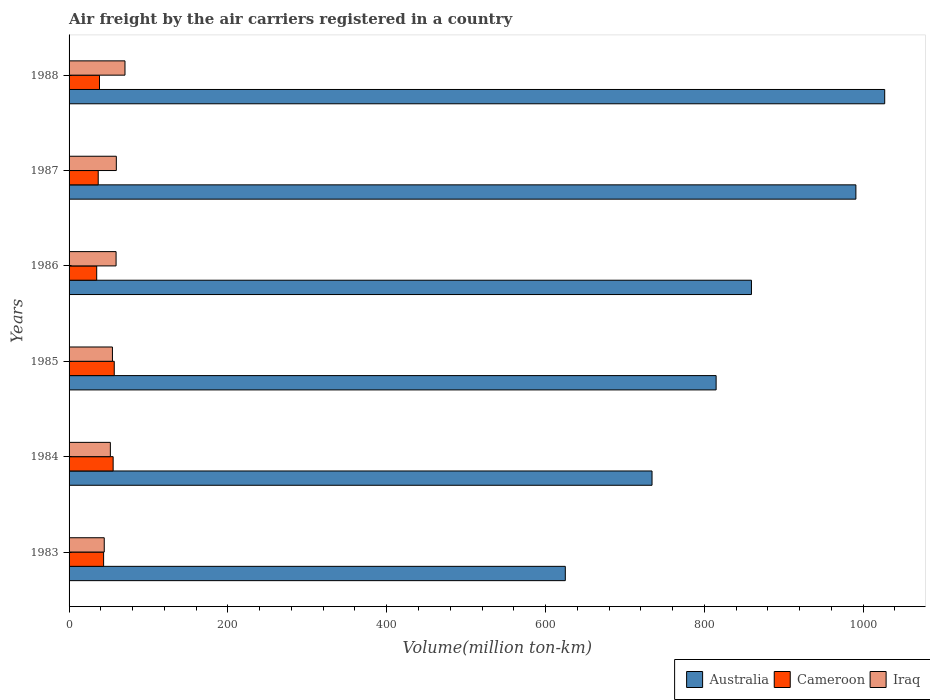How many different coloured bars are there?
Your answer should be compact. 3. Are the number of bars on each tick of the Y-axis equal?
Provide a short and direct response. Yes. How many bars are there on the 3rd tick from the top?
Your answer should be very brief. 3. What is the label of the 5th group of bars from the top?
Your response must be concise. 1984. In how many cases, is the number of bars for a given year not equal to the number of legend labels?
Your response must be concise. 0. What is the volume of the air carriers in Australia in 1987?
Offer a very short reply. 990.8. Across all years, what is the maximum volume of the air carriers in Australia?
Your response must be concise. 1027.1. Across all years, what is the minimum volume of the air carriers in Australia?
Give a very brief answer. 624.9. In which year was the volume of the air carriers in Cameroon maximum?
Provide a short and direct response. 1985. In which year was the volume of the air carriers in Australia minimum?
Ensure brevity in your answer.  1983. What is the total volume of the air carriers in Australia in the graph?
Provide a succinct answer. 5051. What is the difference between the volume of the air carriers in Australia in 1984 and that in 1988?
Your answer should be compact. -293. What is the difference between the volume of the air carriers in Australia in 1988 and the volume of the air carriers in Cameroon in 1984?
Your response must be concise. 971.6. What is the average volume of the air carriers in Iraq per year?
Offer a very short reply. 56.67. In the year 1984, what is the difference between the volume of the air carriers in Iraq and volume of the air carriers in Australia?
Ensure brevity in your answer.  -682.1. What is the ratio of the volume of the air carriers in Iraq in 1983 to that in 1986?
Keep it short and to the point. 0.75. Is the volume of the air carriers in Iraq in 1984 less than that in 1987?
Give a very brief answer. Yes. What is the difference between the highest and the second highest volume of the air carriers in Australia?
Provide a succinct answer. 36.3. What is the difference between the highest and the lowest volume of the air carriers in Cameroon?
Make the answer very short. 22.1. In how many years, is the volume of the air carriers in Cameroon greater than the average volume of the air carriers in Cameroon taken over all years?
Your answer should be compact. 2. Is the sum of the volume of the air carriers in Iraq in 1986 and 1987 greater than the maximum volume of the air carriers in Cameroon across all years?
Make the answer very short. Yes. What does the 1st bar from the top in 1983 represents?
Provide a short and direct response. Iraq. What does the 2nd bar from the bottom in 1987 represents?
Make the answer very short. Cameroon. How many bars are there?
Your response must be concise. 18. Are all the bars in the graph horizontal?
Provide a succinct answer. Yes. How many years are there in the graph?
Give a very brief answer. 6. What is the difference between two consecutive major ticks on the X-axis?
Provide a succinct answer. 200. Does the graph contain any zero values?
Make the answer very short. No. Does the graph contain grids?
Your response must be concise. No. How are the legend labels stacked?
Keep it short and to the point. Horizontal. What is the title of the graph?
Provide a short and direct response. Air freight by the air carriers registered in a country. What is the label or title of the X-axis?
Provide a succinct answer. Volume(million ton-km). What is the label or title of the Y-axis?
Give a very brief answer. Years. What is the Volume(million ton-km) in Australia in 1983?
Offer a terse response. 624.9. What is the Volume(million ton-km) of Cameroon in 1983?
Ensure brevity in your answer.  43.5. What is the Volume(million ton-km) in Iraq in 1983?
Provide a succinct answer. 44.3. What is the Volume(million ton-km) in Australia in 1984?
Provide a succinct answer. 734.1. What is the Volume(million ton-km) of Cameroon in 1984?
Provide a succinct answer. 55.5. What is the Volume(million ton-km) of Iraq in 1984?
Offer a very short reply. 52. What is the Volume(million ton-km) in Australia in 1985?
Provide a succinct answer. 814.8. What is the Volume(million ton-km) in Cameroon in 1985?
Your answer should be very brief. 56.9. What is the Volume(million ton-km) of Iraq in 1985?
Give a very brief answer. 54.6. What is the Volume(million ton-km) in Australia in 1986?
Your answer should be very brief. 859.3. What is the Volume(million ton-km) of Cameroon in 1986?
Ensure brevity in your answer.  34.8. What is the Volume(million ton-km) of Iraq in 1986?
Make the answer very short. 59.2. What is the Volume(million ton-km) in Australia in 1987?
Offer a very short reply. 990.8. What is the Volume(million ton-km) in Cameroon in 1987?
Offer a very short reply. 36.7. What is the Volume(million ton-km) of Iraq in 1987?
Ensure brevity in your answer.  59.5. What is the Volume(million ton-km) of Australia in 1988?
Offer a terse response. 1027.1. What is the Volume(million ton-km) in Cameroon in 1988?
Keep it short and to the point. 38.3. What is the Volume(million ton-km) of Iraq in 1988?
Your answer should be compact. 70.4. Across all years, what is the maximum Volume(million ton-km) of Australia?
Provide a succinct answer. 1027.1. Across all years, what is the maximum Volume(million ton-km) in Cameroon?
Ensure brevity in your answer.  56.9. Across all years, what is the maximum Volume(million ton-km) in Iraq?
Provide a succinct answer. 70.4. Across all years, what is the minimum Volume(million ton-km) in Australia?
Your answer should be compact. 624.9. Across all years, what is the minimum Volume(million ton-km) of Cameroon?
Make the answer very short. 34.8. Across all years, what is the minimum Volume(million ton-km) of Iraq?
Offer a terse response. 44.3. What is the total Volume(million ton-km) of Australia in the graph?
Your response must be concise. 5051. What is the total Volume(million ton-km) in Cameroon in the graph?
Give a very brief answer. 265.7. What is the total Volume(million ton-km) in Iraq in the graph?
Offer a terse response. 340. What is the difference between the Volume(million ton-km) of Australia in 1983 and that in 1984?
Your answer should be very brief. -109.2. What is the difference between the Volume(million ton-km) of Australia in 1983 and that in 1985?
Offer a very short reply. -189.9. What is the difference between the Volume(million ton-km) in Iraq in 1983 and that in 1985?
Your answer should be compact. -10.3. What is the difference between the Volume(million ton-km) in Australia in 1983 and that in 1986?
Offer a terse response. -234.4. What is the difference between the Volume(million ton-km) in Cameroon in 1983 and that in 1986?
Make the answer very short. 8.7. What is the difference between the Volume(million ton-km) of Iraq in 1983 and that in 1986?
Give a very brief answer. -14.9. What is the difference between the Volume(million ton-km) of Australia in 1983 and that in 1987?
Offer a very short reply. -365.9. What is the difference between the Volume(million ton-km) in Cameroon in 1983 and that in 1987?
Your answer should be compact. 6.8. What is the difference between the Volume(million ton-km) of Iraq in 1983 and that in 1987?
Provide a short and direct response. -15.2. What is the difference between the Volume(million ton-km) of Australia in 1983 and that in 1988?
Ensure brevity in your answer.  -402.2. What is the difference between the Volume(million ton-km) in Iraq in 1983 and that in 1988?
Your answer should be very brief. -26.1. What is the difference between the Volume(million ton-km) in Australia in 1984 and that in 1985?
Offer a very short reply. -80.7. What is the difference between the Volume(million ton-km) of Australia in 1984 and that in 1986?
Your answer should be compact. -125.2. What is the difference between the Volume(million ton-km) in Cameroon in 1984 and that in 1986?
Offer a very short reply. 20.7. What is the difference between the Volume(million ton-km) of Iraq in 1984 and that in 1986?
Keep it short and to the point. -7.2. What is the difference between the Volume(million ton-km) in Australia in 1984 and that in 1987?
Your response must be concise. -256.7. What is the difference between the Volume(million ton-km) of Cameroon in 1984 and that in 1987?
Provide a succinct answer. 18.8. What is the difference between the Volume(million ton-km) in Iraq in 1984 and that in 1987?
Make the answer very short. -7.5. What is the difference between the Volume(million ton-km) in Australia in 1984 and that in 1988?
Ensure brevity in your answer.  -293. What is the difference between the Volume(million ton-km) in Cameroon in 1984 and that in 1988?
Your answer should be compact. 17.2. What is the difference between the Volume(million ton-km) in Iraq in 1984 and that in 1988?
Offer a terse response. -18.4. What is the difference between the Volume(million ton-km) in Australia in 1985 and that in 1986?
Your response must be concise. -44.5. What is the difference between the Volume(million ton-km) in Cameroon in 1985 and that in 1986?
Provide a short and direct response. 22.1. What is the difference between the Volume(million ton-km) in Australia in 1985 and that in 1987?
Your answer should be compact. -176. What is the difference between the Volume(million ton-km) in Cameroon in 1985 and that in 1987?
Your answer should be very brief. 20.2. What is the difference between the Volume(million ton-km) of Iraq in 1985 and that in 1987?
Ensure brevity in your answer.  -4.9. What is the difference between the Volume(million ton-km) in Australia in 1985 and that in 1988?
Offer a terse response. -212.3. What is the difference between the Volume(million ton-km) in Cameroon in 1985 and that in 1988?
Make the answer very short. 18.6. What is the difference between the Volume(million ton-km) in Iraq in 1985 and that in 1988?
Ensure brevity in your answer.  -15.8. What is the difference between the Volume(million ton-km) in Australia in 1986 and that in 1987?
Provide a succinct answer. -131.5. What is the difference between the Volume(million ton-km) in Iraq in 1986 and that in 1987?
Make the answer very short. -0.3. What is the difference between the Volume(million ton-km) of Australia in 1986 and that in 1988?
Your answer should be very brief. -167.8. What is the difference between the Volume(million ton-km) in Cameroon in 1986 and that in 1988?
Your answer should be very brief. -3.5. What is the difference between the Volume(million ton-km) of Iraq in 1986 and that in 1988?
Your response must be concise. -11.2. What is the difference between the Volume(million ton-km) of Australia in 1987 and that in 1988?
Provide a succinct answer. -36.3. What is the difference between the Volume(million ton-km) of Iraq in 1987 and that in 1988?
Your response must be concise. -10.9. What is the difference between the Volume(million ton-km) of Australia in 1983 and the Volume(million ton-km) of Cameroon in 1984?
Provide a short and direct response. 569.4. What is the difference between the Volume(million ton-km) in Australia in 1983 and the Volume(million ton-km) in Iraq in 1984?
Make the answer very short. 572.9. What is the difference between the Volume(million ton-km) in Cameroon in 1983 and the Volume(million ton-km) in Iraq in 1984?
Offer a very short reply. -8.5. What is the difference between the Volume(million ton-km) in Australia in 1983 and the Volume(million ton-km) in Cameroon in 1985?
Ensure brevity in your answer.  568. What is the difference between the Volume(million ton-km) of Australia in 1983 and the Volume(million ton-km) of Iraq in 1985?
Provide a short and direct response. 570.3. What is the difference between the Volume(million ton-km) in Cameroon in 1983 and the Volume(million ton-km) in Iraq in 1985?
Offer a terse response. -11.1. What is the difference between the Volume(million ton-km) of Australia in 1983 and the Volume(million ton-km) of Cameroon in 1986?
Provide a succinct answer. 590.1. What is the difference between the Volume(million ton-km) of Australia in 1983 and the Volume(million ton-km) of Iraq in 1986?
Make the answer very short. 565.7. What is the difference between the Volume(million ton-km) of Cameroon in 1983 and the Volume(million ton-km) of Iraq in 1986?
Provide a short and direct response. -15.7. What is the difference between the Volume(million ton-km) in Australia in 1983 and the Volume(million ton-km) in Cameroon in 1987?
Provide a succinct answer. 588.2. What is the difference between the Volume(million ton-km) in Australia in 1983 and the Volume(million ton-km) in Iraq in 1987?
Keep it short and to the point. 565.4. What is the difference between the Volume(million ton-km) in Cameroon in 1983 and the Volume(million ton-km) in Iraq in 1987?
Offer a very short reply. -16. What is the difference between the Volume(million ton-km) of Australia in 1983 and the Volume(million ton-km) of Cameroon in 1988?
Provide a succinct answer. 586.6. What is the difference between the Volume(million ton-km) of Australia in 1983 and the Volume(million ton-km) of Iraq in 1988?
Make the answer very short. 554.5. What is the difference between the Volume(million ton-km) in Cameroon in 1983 and the Volume(million ton-km) in Iraq in 1988?
Your answer should be compact. -26.9. What is the difference between the Volume(million ton-km) of Australia in 1984 and the Volume(million ton-km) of Cameroon in 1985?
Your response must be concise. 677.2. What is the difference between the Volume(million ton-km) of Australia in 1984 and the Volume(million ton-km) of Iraq in 1985?
Make the answer very short. 679.5. What is the difference between the Volume(million ton-km) in Cameroon in 1984 and the Volume(million ton-km) in Iraq in 1985?
Your answer should be compact. 0.9. What is the difference between the Volume(million ton-km) in Australia in 1984 and the Volume(million ton-km) in Cameroon in 1986?
Keep it short and to the point. 699.3. What is the difference between the Volume(million ton-km) of Australia in 1984 and the Volume(million ton-km) of Iraq in 1986?
Ensure brevity in your answer.  674.9. What is the difference between the Volume(million ton-km) in Australia in 1984 and the Volume(million ton-km) in Cameroon in 1987?
Your answer should be compact. 697.4. What is the difference between the Volume(million ton-km) of Australia in 1984 and the Volume(million ton-km) of Iraq in 1987?
Your answer should be compact. 674.6. What is the difference between the Volume(million ton-km) in Cameroon in 1984 and the Volume(million ton-km) in Iraq in 1987?
Ensure brevity in your answer.  -4. What is the difference between the Volume(million ton-km) in Australia in 1984 and the Volume(million ton-km) in Cameroon in 1988?
Provide a succinct answer. 695.8. What is the difference between the Volume(million ton-km) of Australia in 1984 and the Volume(million ton-km) of Iraq in 1988?
Give a very brief answer. 663.7. What is the difference between the Volume(million ton-km) in Cameroon in 1984 and the Volume(million ton-km) in Iraq in 1988?
Provide a succinct answer. -14.9. What is the difference between the Volume(million ton-km) of Australia in 1985 and the Volume(million ton-km) of Cameroon in 1986?
Provide a succinct answer. 780. What is the difference between the Volume(million ton-km) of Australia in 1985 and the Volume(million ton-km) of Iraq in 1986?
Offer a terse response. 755.6. What is the difference between the Volume(million ton-km) of Cameroon in 1985 and the Volume(million ton-km) of Iraq in 1986?
Your answer should be compact. -2.3. What is the difference between the Volume(million ton-km) in Australia in 1985 and the Volume(million ton-km) in Cameroon in 1987?
Offer a very short reply. 778.1. What is the difference between the Volume(million ton-km) in Australia in 1985 and the Volume(million ton-km) in Iraq in 1987?
Offer a very short reply. 755.3. What is the difference between the Volume(million ton-km) in Australia in 1985 and the Volume(million ton-km) in Cameroon in 1988?
Provide a succinct answer. 776.5. What is the difference between the Volume(million ton-km) in Australia in 1985 and the Volume(million ton-km) in Iraq in 1988?
Provide a short and direct response. 744.4. What is the difference between the Volume(million ton-km) of Australia in 1986 and the Volume(million ton-km) of Cameroon in 1987?
Offer a very short reply. 822.6. What is the difference between the Volume(million ton-km) in Australia in 1986 and the Volume(million ton-km) in Iraq in 1987?
Keep it short and to the point. 799.8. What is the difference between the Volume(million ton-km) of Cameroon in 1986 and the Volume(million ton-km) of Iraq in 1987?
Offer a very short reply. -24.7. What is the difference between the Volume(million ton-km) in Australia in 1986 and the Volume(million ton-km) in Cameroon in 1988?
Your answer should be very brief. 821. What is the difference between the Volume(million ton-km) in Australia in 1986 and the Volume(million ton-km) in Iraq in 1988?
Give a very brief answer. 788.9. What is the difference between the Volume(million ton-km) of Cameroon in 1986 and the Volume(million ton-km) of Iraq in 1988?
Offer a terse response. -35.6. What is the difference between the Volume(million ton-km) in Australia in 1987 and the Volume(million ton-km) in Cameroon in 1988?
Your answer should be very brief. 952.5. What is the difference between the Volume(million ton-km) in Australia in 1987 and the Volume(million ton-km) in Iraq in 1988?
Your answer should be very brief. 920.4. What is the difference between the Volume(million ton-km) of Cameroon in 1987 and the Volume(million ton-km) of Iraq in 1988?
Your answer should be very brief. -33.7. What is the average Volume(million ton-km) of Australia per year?
Make the answer very short. 841.83. What is the average Volume(million ton-km) in Cameroon per year?
Make the answer very short. 44.28. What is the average Volume(million ton-km) in Iraq per year?
Ensure brevity in your answer.  56.67. In the year 1983, what is the difference between the Volume(million ton-km) in Australia and Volume(million ton-km) in Cameroon?
Make the answer very short. 581.4. In the year 1983, what is the difference between the Volume(million ton-km) in Australia and Volume(million ton-km) in Iraq?
Make the answer very short. 580.6. In the year 1983, what is the difference between the Volume(million ton-km) of Cameroon and Volume(million ton-km) of Iraq?
Give a very brief answer. -0.8. In the year 1984, what is the difference between the Volume(million ton-km) of Australia and Volume(million ton-km) of Cameroon?
Give a very brief answer. 678.6. In the year 1984, what is the difference between the Volume(million ton-km) of Australia and Volume(million ton-km) of Iraq?
Give a very brief answer. 682.1. In the year 1985, what is the difference between the Volume(million ton-km) in Australia and Volume(million ton-km) in Cameroon?
Give a very brief answer. 757.9. In the year 1985, what is the difference between the Volume(million ton-km) of Australia and Volume(million ton-km) of Iraq?
Your answer should be very brief. 760.2. In the year 1986, what is the difference between the Volume(million ton-km) of Australia and Volume(million ton-km) of Cameroon?
Keep it short and to the point. 824.5. In the year 1986, what is the difference between the Volume(million ton-km) of Australia and Volume(million ton-km) of Iraq?
Provide a succinct answer. 800.1. In the year 1986, what is the difference between the Volume(million ton-km) of Cameroon and Volume(million ton-km) of Iraq?
Your answer should be very brief. -24.4. In the year 1987, what is the difference between the Volume(million ton-km) in Australia and Volume(million ton-km) in Cameroon?
Keep it short and to the point. 954.1. In the year 1987, what is the difference between the Volume(million ton-km) in Australia and Volume(million ton-km) in Iraq?
Provide a succinct answer. 931.3. In the year 1987, what is the difference between the Volume(million ton-km) in Cameroon and Volume(million ton-km) in Iraq?
Your response must be concise. -22.8. In the year 1988, what is the difference between the Volume(million ton-km) of Australia and Volume(million ton-km) of Cameroon?
Offer a very short reply. 988.8. In the year 1988, what is the difference between the Volume(million ton-km) of Australia and Volume(million ton-km) of Iraq?
Your answer should be very brief. 956.7. In the year 1988, what is the difference between the Volume(million ton-km) in Cameroon and Volume(million ton-km) in Iraq?
Provide a succinct answer. -32.1. What is the ratio of the Volume(million ton-km) in Australia in 1983 to that in 1984?
Keep it short and to the point. 0.85. What is the ratio of the Volume(million ton-km) in Cameroon in 1983 to that in 1984?
Give a very brief answer. 0.78. What is the ratio of the Volume(million ton-km) in Iraq in 1983 to that in 1984?
Ensure brevity in your answer.  0.85. What is the ratio of the Volume(million ton-km) in Australia in 1983 to that in 1985?
Offer a terse response. 0.77. What is the ratio of the Volume(million ton-km) in Cameroon in 1983 to that in 1985?
Provide a succinct answer. 0.76. What is the ratio of the Volume(million ton-km) of Iraq in 1983 to that in 1985?
Provide a succinct answer. 0.81. What is the ratio of the Volume(million ton-km) of Australia in 1983 to that in 1986?
Your answer should be very brief. 0.73. What is the ratio of the Volume(million ton-km) in Cameroon in 1983 to that in 1986?
Your answer should be compact. 1.25. What is the ratio of the Volume(million ton-km) of Iraq in 1983 to that in 1986?
Offer a very short reply. 0.75. What is the ratio of the Volume(million ton-km) in Australia in 1983 to that in 1987?
Provide a succinct answer. 0.63. What is the ratio of the Volume(million ton-km) of Cameroon in 1983 to that in 1987?
Make the answer very short. 1.19. What is the ratio of the Volume(million ton-km) in Iraq in 1983 to that in 1987?
Keep it short and to the point. 0.74. What is the ratio of the Volume(million ton-km) in Australia in 1983 to that in 1988?
Offer a very short reply. 0.61. What is the ratio of the Volume(million ton-km) in Cameroon in 1983 to that in 1988?
Provide a succinct answer. 1.14. What is the ratio of the Volume(million ton-km) of Iraq in 1983 to that in 1988?
Your response must be concise. 0.63. What is the ratio of the Volume(million ton-km) of Australia in 1984 to that in 1985?
Provide a short and direct response. 0.9. What is the ratio of the Volume(million ton-km) in Cameroon in 1984 to that in 1985?
Offer a terse response. 0.98. What is the ratio of the Volume(million ton-km) of Iraq in 1984 to that in 1985?
Give a very brief answer. 0.95. What is the ratio of the Volume(million ton-km) of Australia in 1984 to that in 1986?
Give a very brief answer. 0.85. What is the ratio of the Volume(million ton-km) of Cameroon in 1984 to that in 1986?
Offer a terse response. 1.59. What is the ratio of the Volume(million ton-km) in Iraq in 1984 to that in 1986?
Your answer should be compact. 0.88. What is the ratio of the Volume(million ton-km) of Australia in 1984 to that in 1987?
Offer a very short reply. 0.74. What is the ratio of the Volume(million ton-km) in Cameroon in 1984 to that in 1987?
Provide a short and direct response. 1.51. What is the ratio of the Volume(million ton-km) of Iraq in 1984 to that in 1987?
Provide a succinct answer. 0.87. What is the ratio of the Volume(million ton-km) in Australia in 1984 to that in 1988?
Your answer should be very brief. 0.71. What is the ratio of the Volume(million ton-km) in Cameroon in 1984 to that in 1988?
Offer a very short reply. 1.45. What is the ratio of the Volume(million ton-km) in Iraq in 1984 to that in 1988?
Keep it short and to the point. 0.74. What is the ratio of the Volume(million ton-km) of Australia in 1985 to that in 1986?
Your answer should be compact. 0.95. What is the ratio of the Volume(million ton-km) in Cameroon in 1985 to that in 1986?
Provide a succinct answer. 1.64. What is the ratio of the Volume(million ton-km) of Iraq in 1985 to that in 1986?
Ensure brevity in your answer.  0.92. What is the ratio of the Volume(million ton-km) in Australia in 1985 to that in 1987?
Keep it short and to the point. 0.82. What is the ratio of the Volume(million ton-km) in Cameroon in 1985 to that in 1987?
Give a very brief answer. 1.55. What is the ratio of the Volume(million ton-km) of Iraq in 1985 to that in 1987?
Ensure brevity in your answer.  0.92. What is the ratio of the Volume(million ton-km) in Australia in 1985 to that in 1988?
Keep it short and to the point. 0.79. What is the ratio of the Volume(million ton-km) of Cameroon in 1985 to that in 1988?
Provide a succinct answer. 1.49. What is the ratio of the Volume(million ton-km) in Iraq in 1985 to that in 1988?
Your answer should be very brief. 0.78. What is the ratio of the Volume(million ton-km) in Australia in 1986 to that in 1987?
Make the answer very short. 0.87. What is the ratio of the Volume(million ton-km) in Cameroon in 1986 to that in 1987?
Provide a succinct answer. 0.95. What is the ratio of the Volume(million ton-km) in Australia in 1986 to that in 1988?
Provide a short and direct response. 0.84. What is the ratio of the Volume(million ton-km) of Cameroon in 1986 to that in 1988?
Make the answer very short. 0.91. What is the ratio of the Volume(million ton-km) in Iraq in 1986 to that in 1988?
Provide a short and direct response. 0.84. What is the ratio of the Volume(million ton-km) in Australia in 1987 to that in 1988?
Ensure brevity in your answer.  0.96. What is the ratio of the Volume(million ton-km) of Cameroon in 1987 to that in 1988?
Your answer should be compact. 0.96. What is the ratio of the Volume(million ton-km) of Iraq in 1987 to that in 1988?
Give a very brief answer. 0.85. What is the difference between the highest and the second highest Volume(million ton-km) in Australia?
Keep it short and to the point. 36.3. What is the difference between the highest and the second highest Volume(million ton-km) of Cameroon?
Your answer should be compact. 1.4. What is the difference between the highest and the lowest Volume(million ton-km) of Australia?
Your response must be concise. 402.2. What is the difference between the highest and the lowest Volume(million ton-km) of Cameroon?
Your answer should be compact. 22.1. What is the difference between the highest and the lowest Volume(million ton-km) in Iraq?
Make the answer very short. 26.1. 